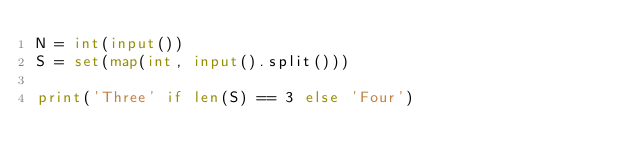Convert code to text. <code><loc_0><loc_0><loc_500><loc_500><_Python_>N = int(input())
S = set(map(int, input().split()))

print('Three' if len(S) == 3 else 'Four')
</code> 